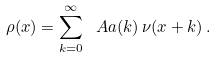Convert formula to latex. <formula><loc_0><loc_0><loc_500><loc_500>\rho ( x ) = \sum _ { k = 0 } ^ { \infty } \ A a ( k ) \, \nu ( x + k ) \, .</formula> 